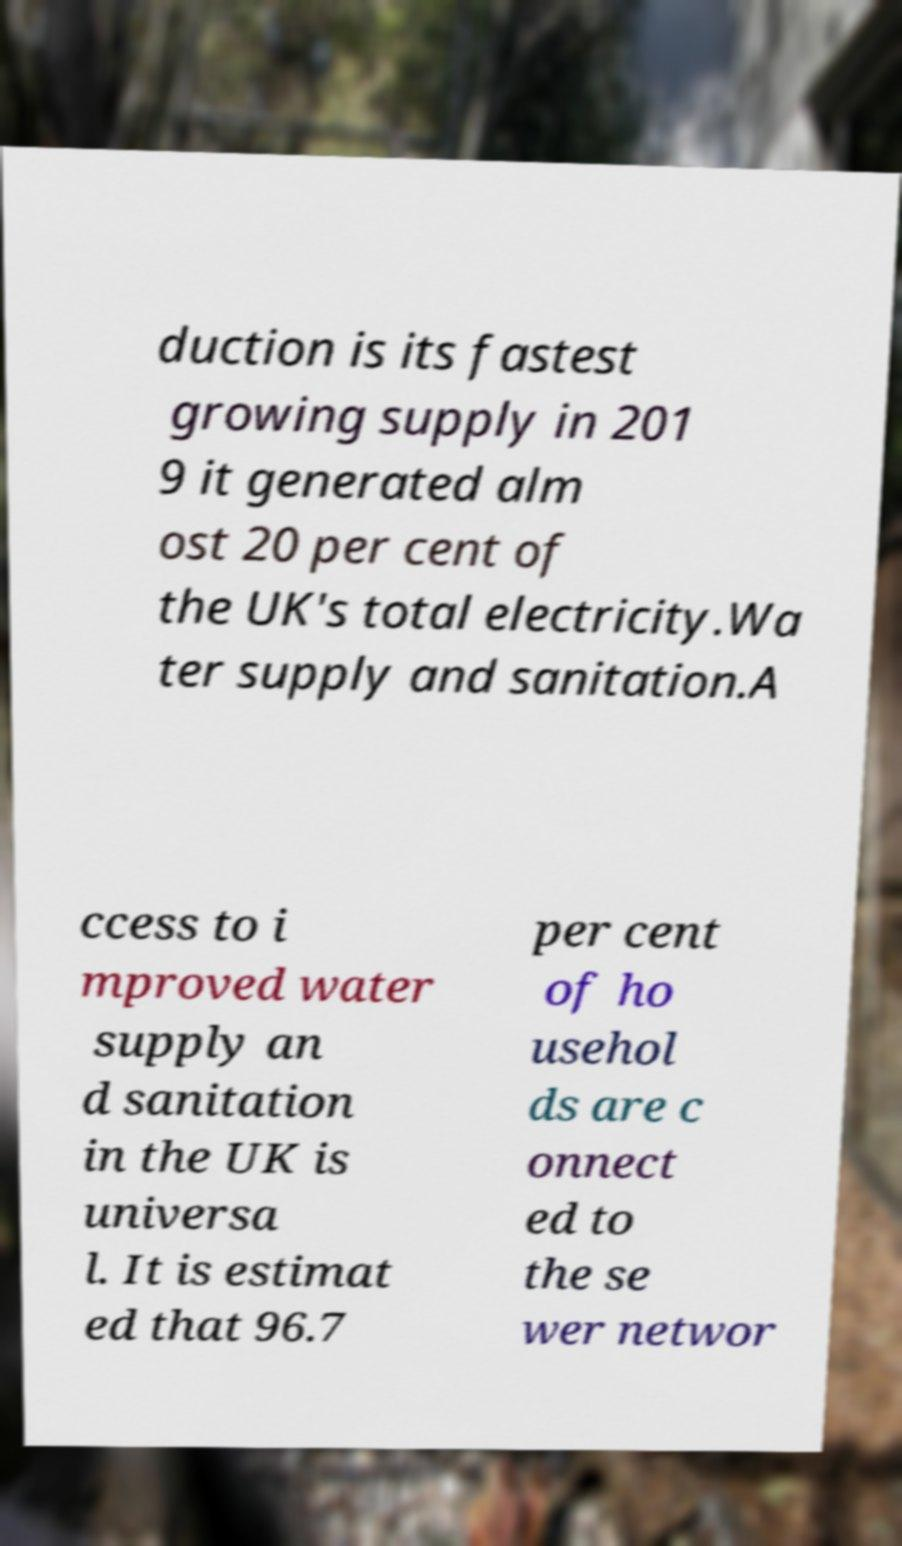There's text embedded in this image that I need extracted. Can you transcribe it verbatim? duction is its fastest growing supply in 201 9 it generated alm ost 20 per cent of the UK's total electricity.Wa ter supply and sanitation.A ccess to i mproved water supply an d sanitation in the UK is universa l. It is estimat ed that 96.7 per cent of ho usehol ds are c onnect ed to the se wer networ 